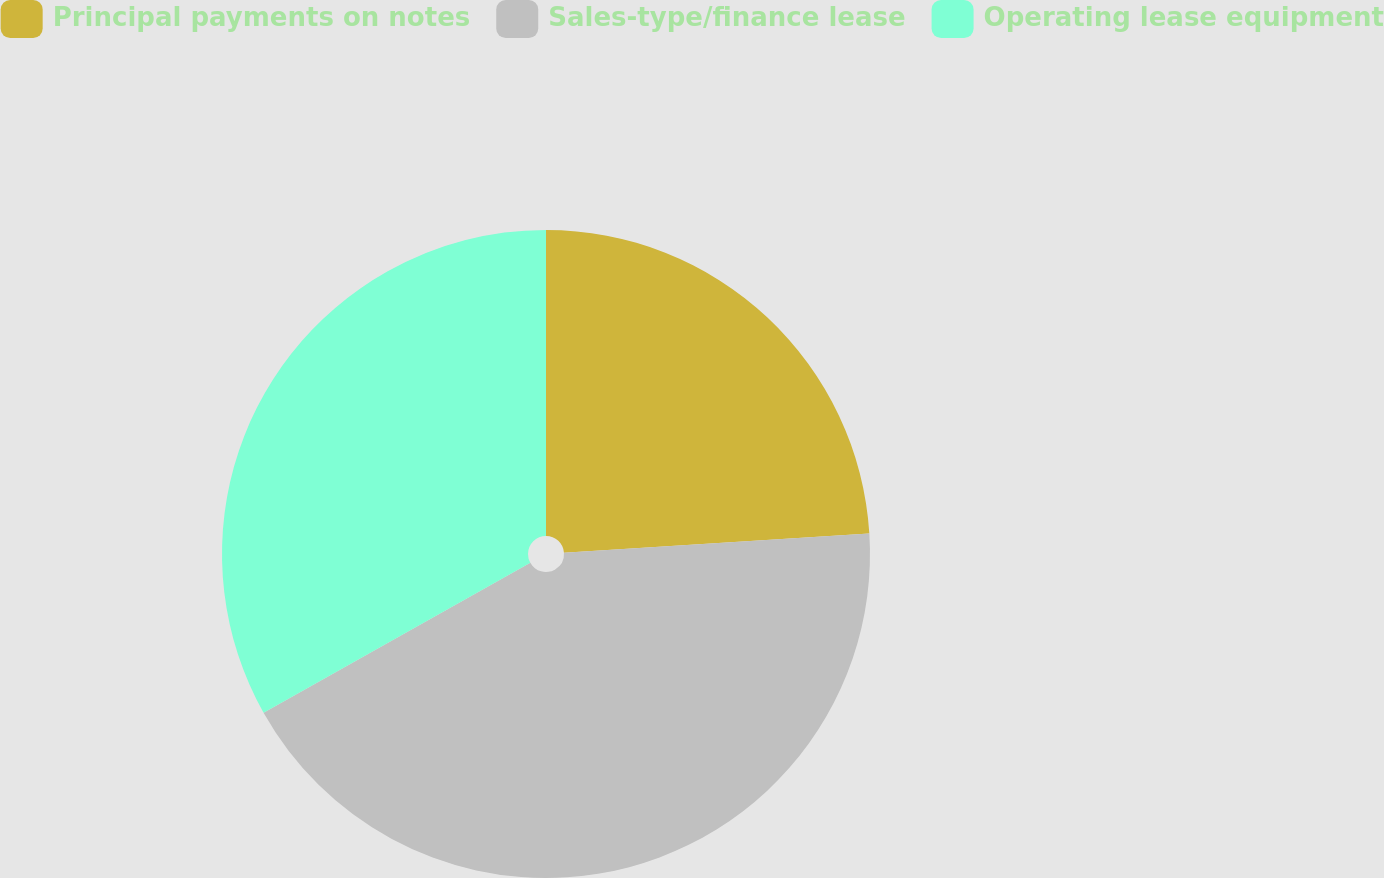Convert chart to OTSL. <chart><loc_0><loc_0><loc_500><loc_500><pie_chart><fcel>Principal payments on notes<fcel>Sales-type/finance lease<fcel>Operating lease equipment<nl><fcel>23.99%<fcel>42.86%<fcel>33.15%<nl></chart> 